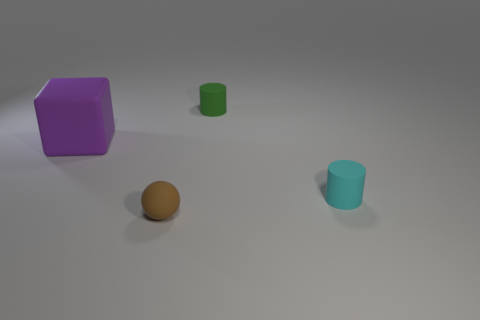Add 3 brown rubber objects. How many objects exist? 7 Subtract 1 cylinders. How many cylinders are left? 1 Subtract all cubes. How many objects are left? 3 Subtract all blue spheres. How many yellow cubes are left? 0 Subtract all blue metal cylinders. Subtract all cylinders. How many objects are left? 2 Add 4 cyan rubber things. How many cyan rubber things are left? 5 Add 2 large green matte spheres. How many large green matte spheres exist? 2 Subtract 0 purple cylinders. How many objects are left? 4 Subtract all red cubes. Subtract all gray balls. How many cubes are left? 1 